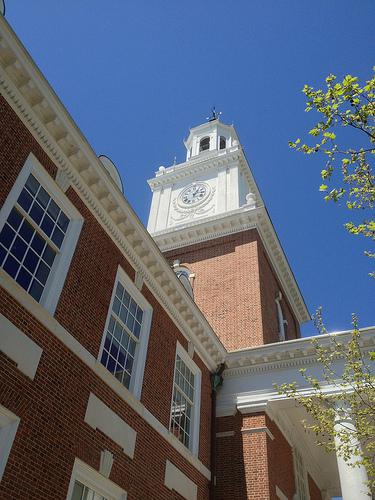Question: what is the color of the sky?
Choices:
A. White.
B. Pink.
C. Black.
D. Blue.
Answer with the letter. Answer: D Question: what is the weather condition?
Choices:
A. Sunny.
B. Snowing.
C. Thunder and lightening.
D. Humid.
Answer with the letter. Answer: A Question: who is on the top of the tower?
Choices:
A. No one.
B. The men.
C. Some kids.
D. The ladies.
Answer with the letter. Answer: A Question: when did the building built?
Choices:
A. Last week.
B. Right now.
C. Years ago.
D. Last year.
Answer with the letter. Answer: C Question: how many birds flying?
Choices:
A. One.
B. Two.
C. Three.
D. Zero.
Answer with the letter. Answer: D Question: what is the color of the tower?
Choices:
A. Blue.
B. White.
C. Gray.
D. Brown.
Answer with the letter. Answer: B Question: why the day is bright?
Choices:
A. It is sunny.
B. It's morning.
C. There are no clouds.
D. It is noon.
Answer with the letter. Answer: B 